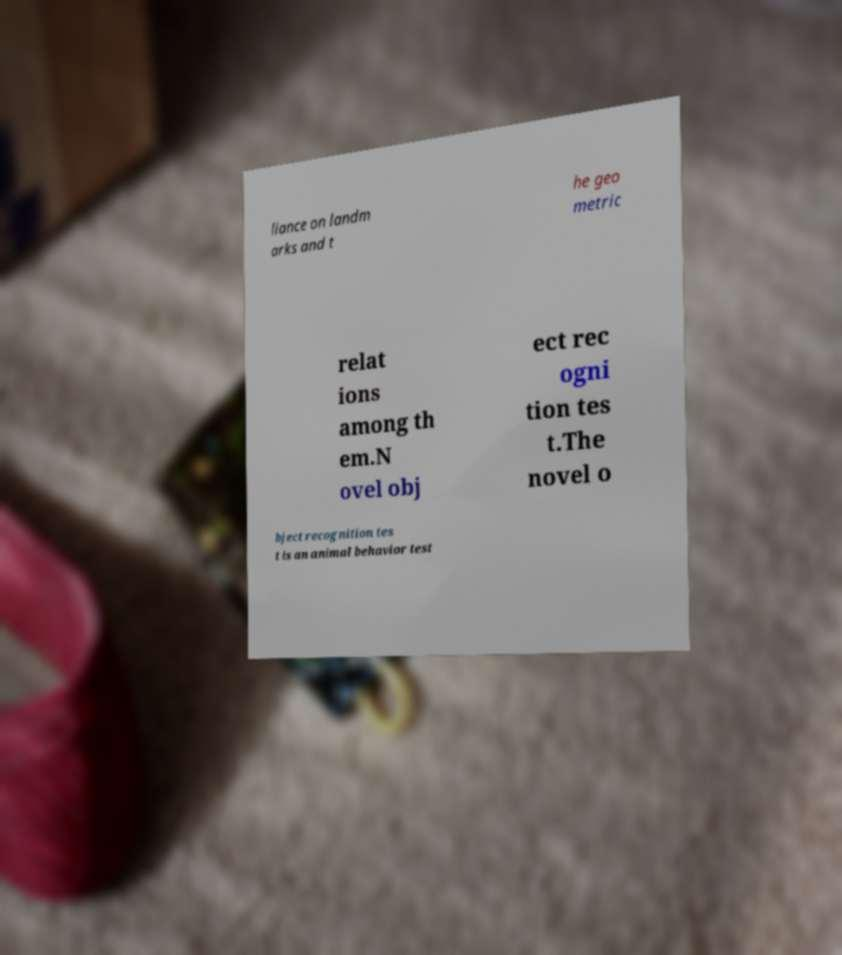Please identify and transcribe the text found in this image. liance on landm arks and t he geo metric relat ions among th em.N ovel obj ect rec ogni tion tes t.The novel o bject recognition tes t is an animal behavior test 